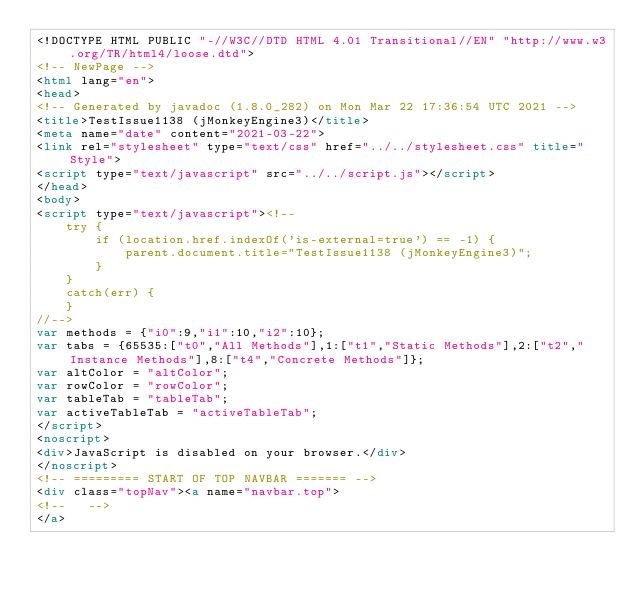<code> <loc_0><loc_0><loc_500><loc_500><_HTML_><!DOCTYPE HTML PUBLIC "-//W3C//DTD HTML 4.01 Transitional//EN" "http://www.w3.org/TR/html4/loose.dtd">
<!-- NewPage -->
<html lang="en">
<head>
<!-- Generated by javadoc (1.8.0_282) on Mon Mar 22 17:36:54 UTC 2021 -->
<title>TestIssue1138 (jMonkeyEngine3)</title>
<meta name="date" content="2021-03-22">
<link rel="stylesheet" type="text/css" href="../../stylesheet.css" title="Style">
<script type="text/javascript" src="../../script.js"></script>
</head>
<body>
<script type="text/javascript"><!--
    try {
        if (location.href.indexOf('is-external=true') == -1) {
            parent.document.title="TestIssue1138 (jMonkeyEngine3)";
        }
    }
    catch(err) {
    }
//-->
var methods = {"i0":9,"i1":10,"i2":10};
var tabs = {65535:["t0","All Methods"],1:["t1","Static Methods"],2:["t2","Instance Methods"],8:["t4","Concrete Methods"]};
var altColor = "altColor";
var rowColor = "rowColor";
var tableTab = "tableTab";
var activeTableTab = "activeTableTab";
</script>
<noscript>
<div>JavaScript is disabled on your browser.</div>
</noscript>
<!-- ========= START OF TOP NAVBAR ======= -->
<div class="topNav"><a name="navbar.top">
<!--   -->
</a></code> 